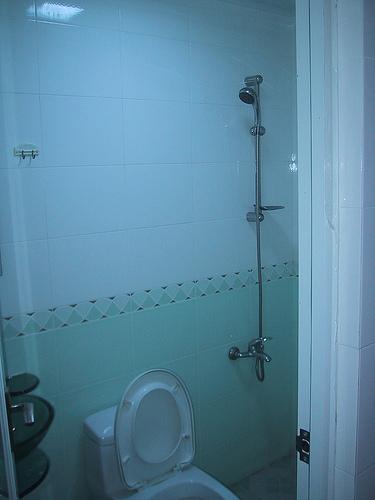How many door handles?
Give a very brief answer. 1. How many toilets are there?
Give a very brief answer. 1. 